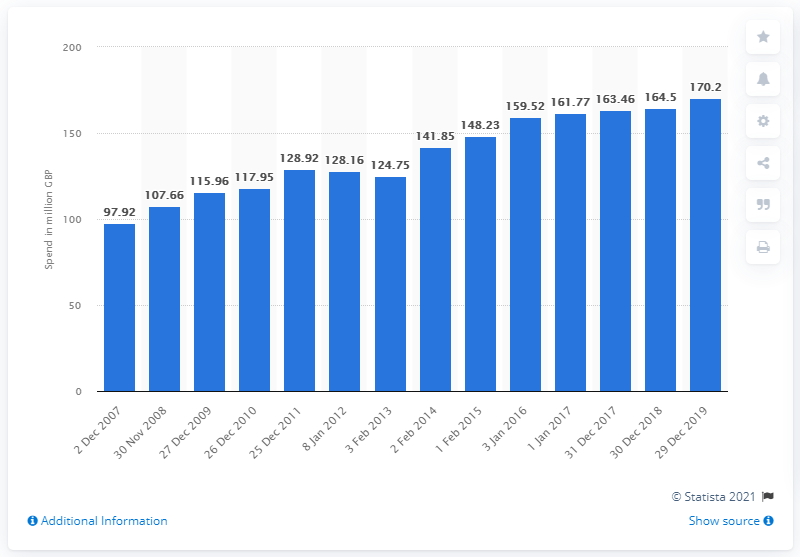Draw attention to some important aspects in this diagram. The expenditure of fresh pasta in the UK by the end of 2019 was approximately 170.2 million pounds. 